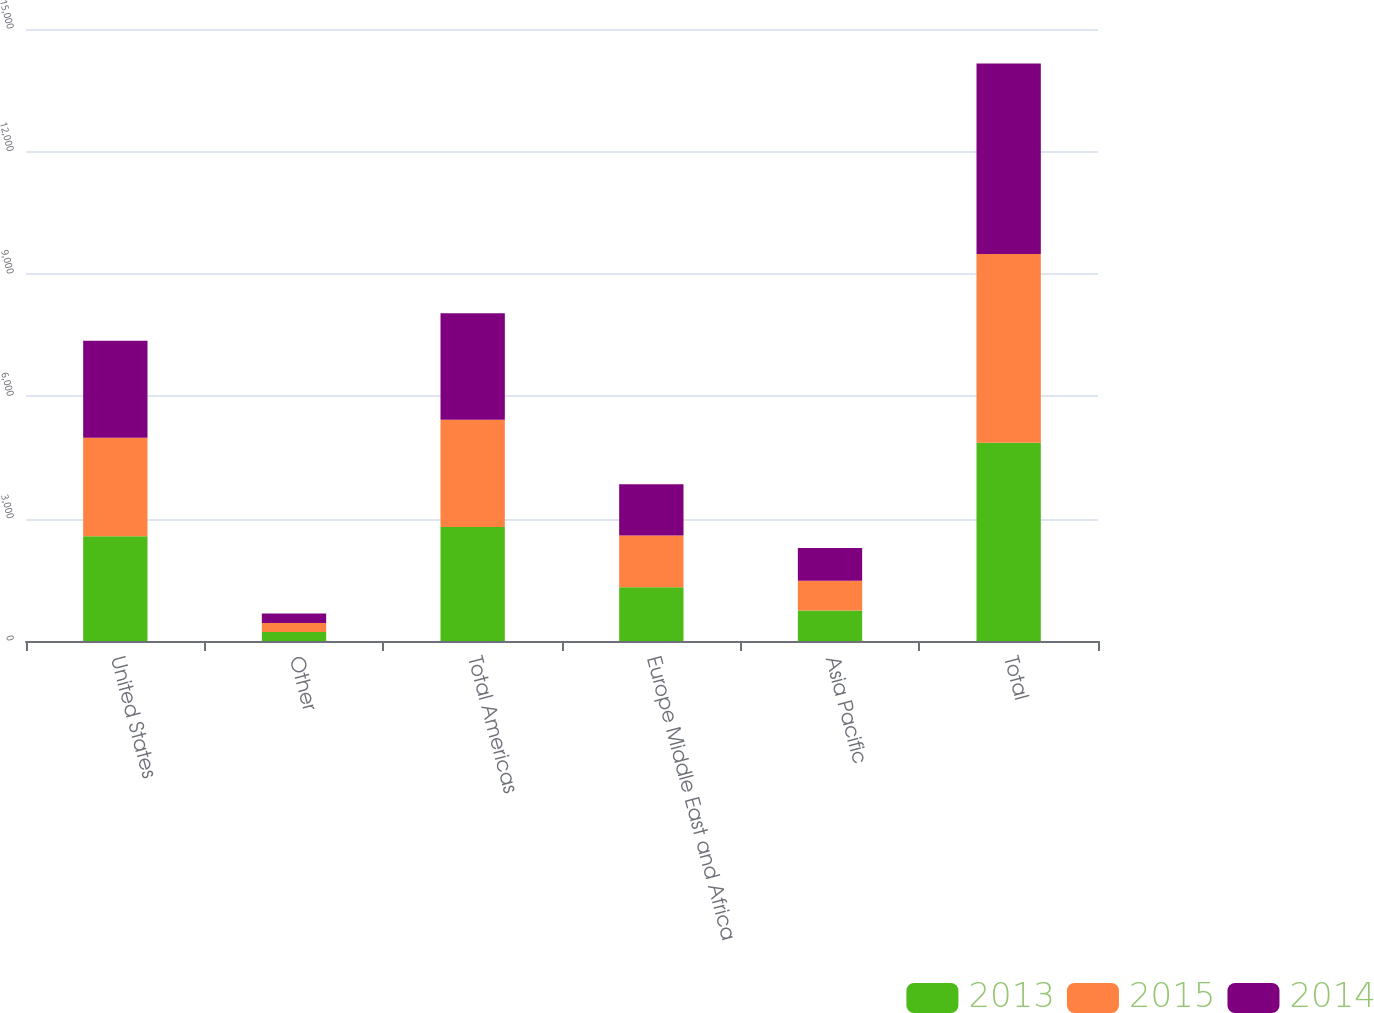<chart> <loc_0><loc_0><loc_500><loc_500><stacked_bar_chart><ecel><fcel>United States<fcel>Other<fcel>Total Americas<fcel>Europe Middle East and Africa<fcel>Asia Pacific<fcel>Total<nl><fcel>2013<fcel>2568.6<fcel>223.6<fcel>2792.2<fcel>1320.3<fcel>745.3<fcel>4857.8<nl><fcel>2015<fcel>2410.6<fcel>219.7<fcel>2630.3<fcel>1263.3<fcel>733.5<fcel>4627.1<nl><fcel>2014<fcel>2381.5<fcel>232<fcel>2613.5<fcel>1256.9<fcel>798.7<fcel>4669.1<nl></chart> 